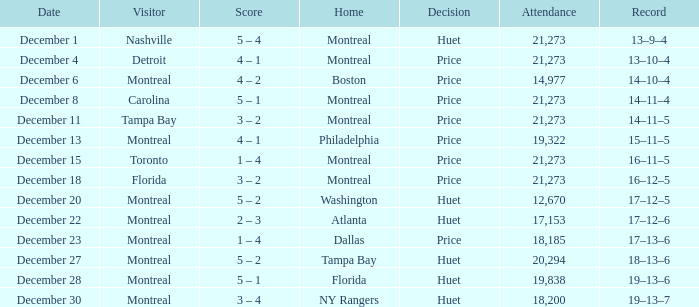What is the record on December 4? 13–10–4. 